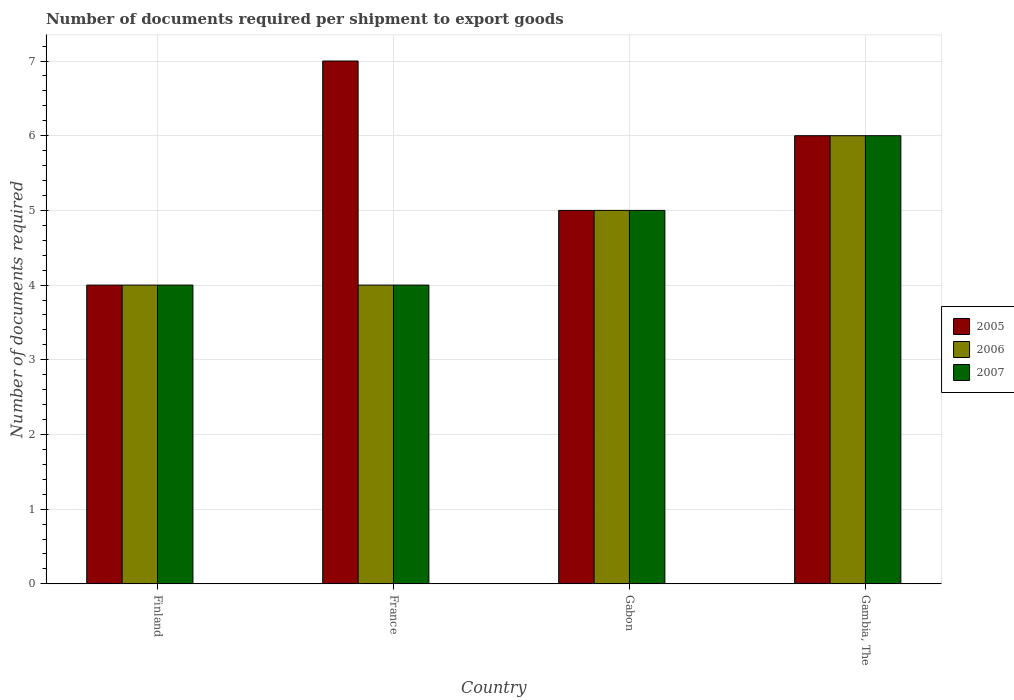How many different coloured bars are there?
Your answer should be very brief. 3. How many bars are there on the 2nd tick from the left?
Keep it short and to the point. 3. How many bars are there on the 2nd tick from the right?
Provide a short and direct response. 3. What is the label of the 3rd group of bars from the left?
Your response must be concise. Gabon. In how many cases, is the number of bars for a given country not equal to the number of legend labels?
Give a very brief answer. 0. Across all countries, what is the minimum number of documents required per shipment to export goods in 2005?
Keep it short and to the point. 4. In which country was the number of documents required per shipment to export goods in 2007 maximum?
Provide a succinct answer. Gambia, The. What is the average number of documents required per shipment to export goods in 2006 per country?
Your response must be concise. 4.75. What is the ratio of the number of documents required per shipment to export goods in 2005 in France to that in Gambia, The?
Your answer should be compact. 1.17. Is the number of documents required per shipment to export goods in 2006 in Finland less than that in Gambia, The?
Make the answer very short. Yes. What is the difference between the highest and the second highest number of documents required per shipment to export goods in 2005?
Offer a terse response. -1. What is the difference between the highest and the lowest number of documents required per shipment to export goods in 2007?
Your response must be concise. 2. In how many countries, is the number of documents required per shipment to export goods in 2006 greater than the average number of documents required per shipment to export goods in 2006 taken over all countries?
Offer a very short reply. 2. Is the sum of the number of documents required per shipment to export goods in 2006 in Finland and Gambia, The greater than the maximum number of documents required per shipment to export goods in 2005 across all countries?
Ensure brevity in your answer.  Yes. What does the 1st bar from the right in Gambia, The represents?
Provide a short and direct response. 2007. Is it the case that in every country, the sum of the number of documents required per shipment to export goods in 2007 and number of documents required per shipment to export goods in 2005 is greater than the number of documents required per shipment to export goods in 2006?
Ensure brevity in your answer.  Yes. Are all the bars in the graph horizontal?
Offer a very short reply. No. Does the graph contain any zero values?
Provide a succinct answer. No. Does the graph contain grids?
Offer a very short reply. Yes. Where does the legend appear in the graph?
Ensure brevity in your answer.  Center right. How many legend labels are there?
Your answer should be very brief. 3. What is the title of the graph?
Your response must be concise. Number of documents required per shipment to export goods. Does "1984" appear as one of the legend labels in the graph?
Your answer should be very brief. No. What is the label or title of the X-axis?
Offer a very short reply. Country. What is the label or title of the Y-axis?
Make the answer very short. Number of documents required. What is the Number of documents required of 2007 in Finland?
Your response must be concise. 4. What is the Number of documents required of 2006 in France?
Provide a short and direct response. 4. What is the Number of documents required of 2007 in France?
Your answer should be very brief. 4. What is the Number of documents required of 2006 in Gabon?
Ensure brevity in your answer.  5. What is the Number of documents required in 2007 in Gabon?
Your answer should be very brief. 5. What is the Number of documents required in 2005 in Gambia, The?
Offer a terse response. 6. What is the Number of documents required of 2006 in Gambia, The?
Ensure brevity in your answer.  6. Across all countries, what is the minimum Number of documents required of 2007?
Provide a succinct answer. 4. What is the total Number of documents required of 2006 in the graph?
Provide a succinct answer. 19. What is the difference between the Number of documents required of 2005 in Finland and that in France?
Provide a succinct answer. -3. What is the difference between the Number of documents required of 2007 in Finland and that in France?
Provide a succinct answer. 0. What is the difference between the Number of documents required of 2005 in Finland and that in Gabon?
Your answer should be compact. -1. What is the difference between the Number of documents required in 2005 in Finland and that in Gambia, The?
Provide a short and direct response. -2. What is the difference between the Number of documents required in 2006 in France and that in Gabon?
Ensure brevity in your answer.  -1. What is the difference between the Number of documents required in 2005 in France and that in Gambia, The?
Offer a terse response. 1. What is the difference between the Number of documents required of 2005 in Gabon and that in Gambia, The?
Your answer should be compact. -1. What is the difference between the Number of documents required of 2006 in Gabon and that in Gambia, The?
Offer a terse response. -1. What is the difference between the Number of documents required in 2005 in Finland and the Number of documents required in 2006 in France?
Offer a very short reply. 0. What is the difference between the Number of documents required of 2005 in Finland and the Number of documents required of 2006 in Gabon?
Your response must be concise. -1. What is the difference between the Number of documents required in 2005 in Finland and the Number of documents required in 2007 in Gabon?
Make the answer very short. -1. What is the difference between the Number of documents required of 2006 in Finland and the Number of documents required of 2007 in Gabon?
Your response must be concise. -1. What is the difference between the Number of documents required of 2005 in Finland and the Number of documents required of 2006 in Gambia, The?
Make the answer very short. -2. What is the difference between the Number of documents required of 2005 in Finland and the Number of documents required of 2007 in Gambia, The?
Provide a short and direct response. -2. What is the difference between the Number of documents required of 2006 in Finland and the Number of documents required of 2007 in Gambia, The?
Provide a succinct answer. -2. What is the difference between the Number of documents required in 2005 in France and the Number of documents required in 2007 in Gabon?
Your response must be concise. 2. What is the difference between the Number of documents required in 2005 in France and the Number of documents required in 2006 in Gambia, The?
Provide a short and direct response. 1. What is the difference between the Number of documents required of 2006 in France and the Number of documents required of 2007 in Gambia, The?
Provide a short and direct response. -2. What is the difference between the Number of documents required in 2006 in Gabon and the Number of documents required in 2007 in Gambia, The?
Make the answer very short. -1. What is the average Number of documents required of 2005 per country?
Your answer should be compact. 5.5. What is the average Number of documents required of 2006 per country?
Provide a succinct answer. 4.75. What is the average Number of documents required of 2007 per country?
Provide a succinct answer. 4.75. What is the difference between the Number of documents required of 2005 and Number of documents required of 2006 in Finland?
Your answer should be very brief. 0. What is the difference between the Number of documents required in 2005 and Number of documents required in 2006 in France?
Give a very brief answer. 3. What is the difference between the Number of documents required in 2005 and Number of documents required in 2006 in Gabon?
Your answer should be very brief. 0. What is the difference between the Number of documents required in 2006 and Number of documents required in 2007 in Gambia, The?
Make the answer very short. 0. What is the ratio of the Number of documents required of 2007 in Finland to that in France?
Give a very brief answer. 1. What is the ratio of the Number of documents required in 2005 in Finland to that in Gabon?
Keep it short and to the point. 0.8. What is the ratio of the Number of documents required in 2005 in Finland to that in Gambia, The?
Your response must be concise. 0.67. What is the ratio of the Number of documents required of 2006 in Finland to that in Gambia, The?
Make the answer very short. 0.67. What is the ratio of the Number of documents required in 2007 in Finland to that in Gambia, The?
Give a very brief answer. 0.67. What is the ratio of the Number of documents required in 2005 in France to that in Gabon?
Offer a terse response. 1.4. What is the ratio of the Number of documents required of 2005 in France to that in Gambia, The?
Keep it short and to the point. 1.17. What is the ratio of the Number of documents required in 2006 in France to that in Gambia, The?
Keep it short and to the point. 0.67. What is the ratio of the Number of documents required in 2007 in France to that in Gambia, The?
Your response must be concise. 0.67. What is the difference between the highest and the second highest Number of documents required in 2006?
Ensure brevity in your answer.  1. What is the difference between the highest and the second highest Number of documents required of 2007?
Your response must be concise. 1. What is the difference between the highest and the lowest Number of documents required of 2007?
Your answer should be very brief. 2. 